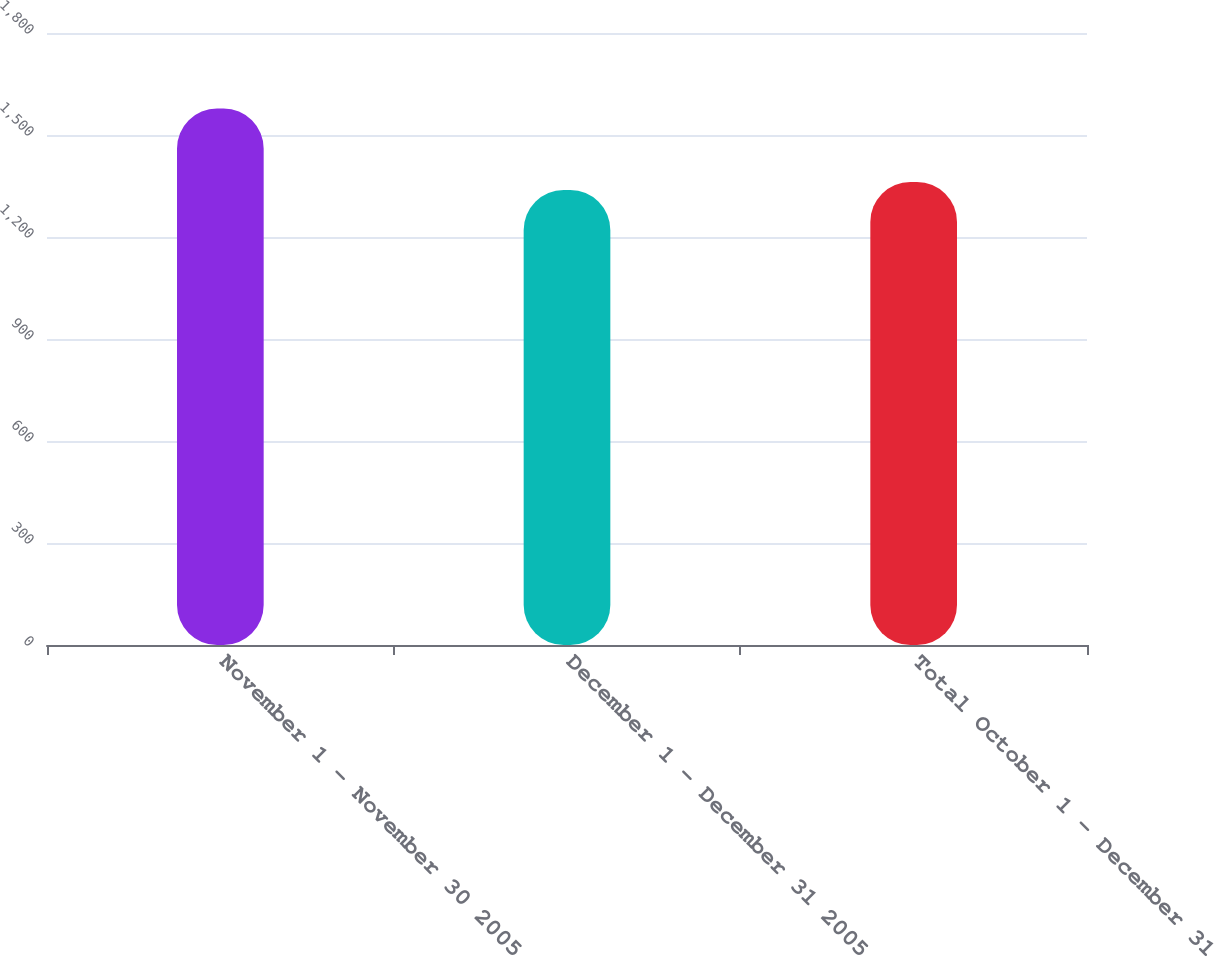Convert chart to OTSL. <chart><loc_0><loc_0><loc_500><loc_500><bar_chart><fcel>November 1 - November 30 2005<fcel>December 1 - December 31 2005<fcel>Total October 1 - December 31<nl><fcel>1578<fcel>1338<fcel>1362<nl></chart> 